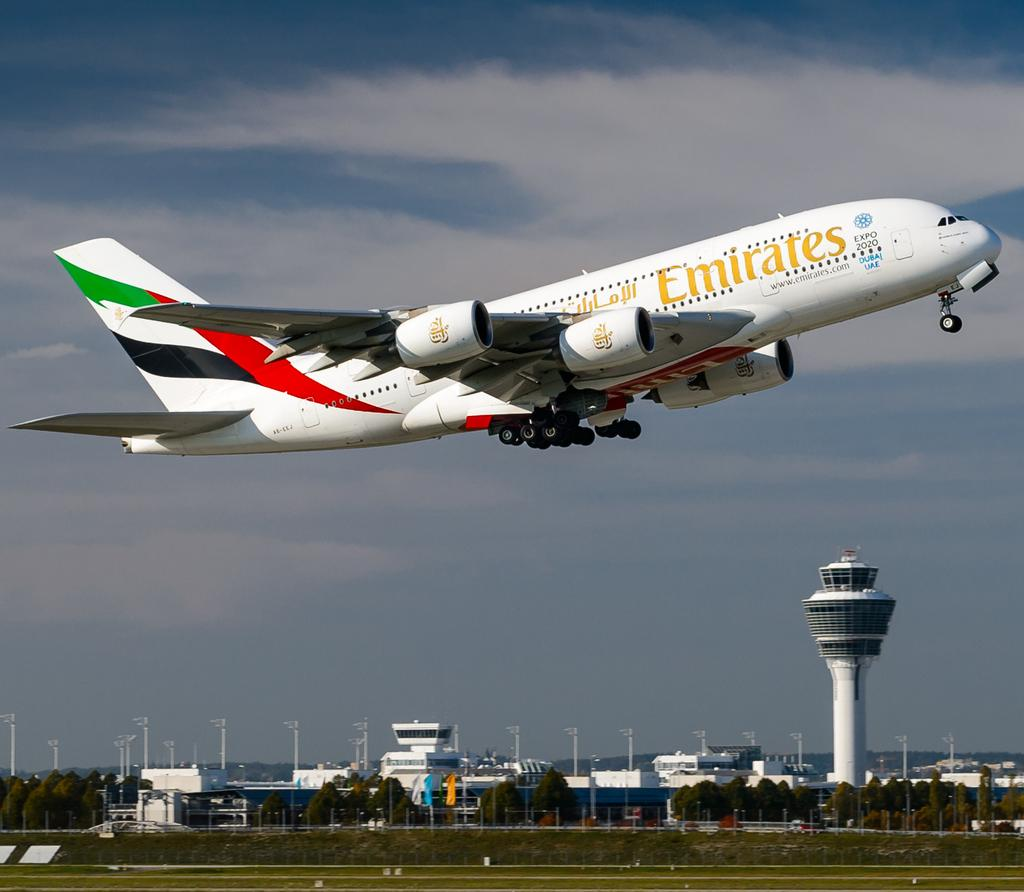<image>
Relay a brief, clear account of the picture shown. A plate from Emirates airlines is taking off and still close to the ground. 